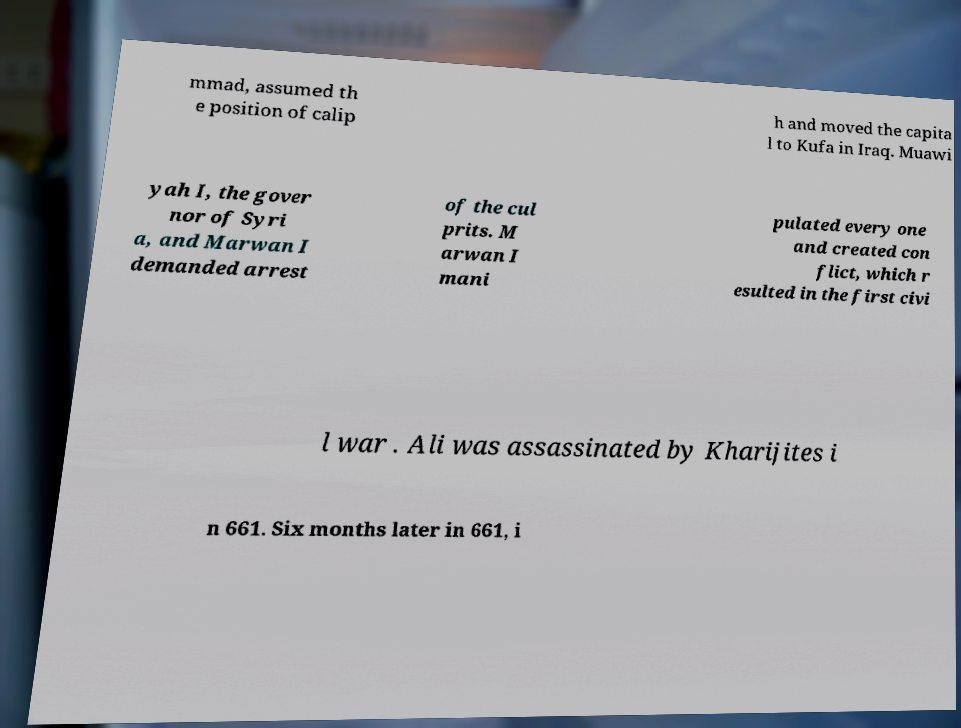Could you assist in decoding the text presented in this image and type it out clearly? mmad, assumed th e position of calip h and moved the capita l to Kufa in Iraq. Muawi yah I, the gover nor of Syri a, and Marwan I demanded arrest of the cul prits. M arwan I mani pulated every one and created con flict, which r esulted in the first civi l war . Ali was assassinated by Kharijites i n 661. Six months later in 661, i 